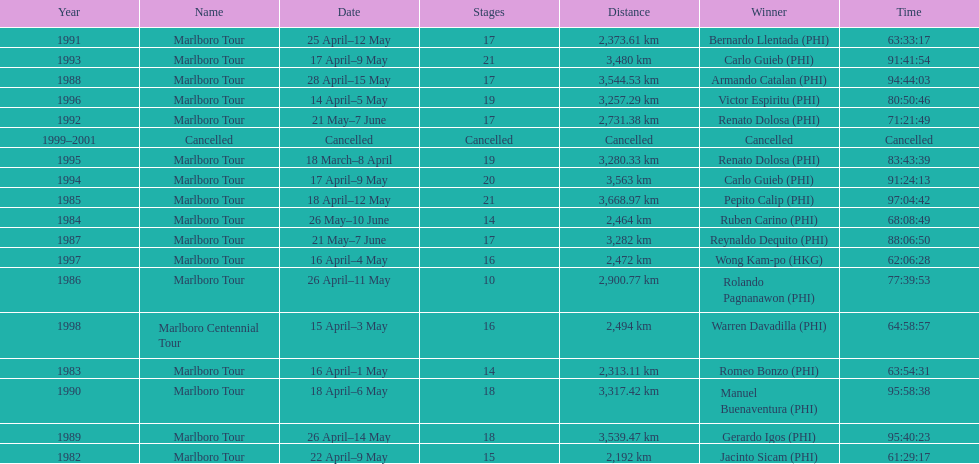Who is listed below romeo bonzo? Ruben Carino (PHI). 